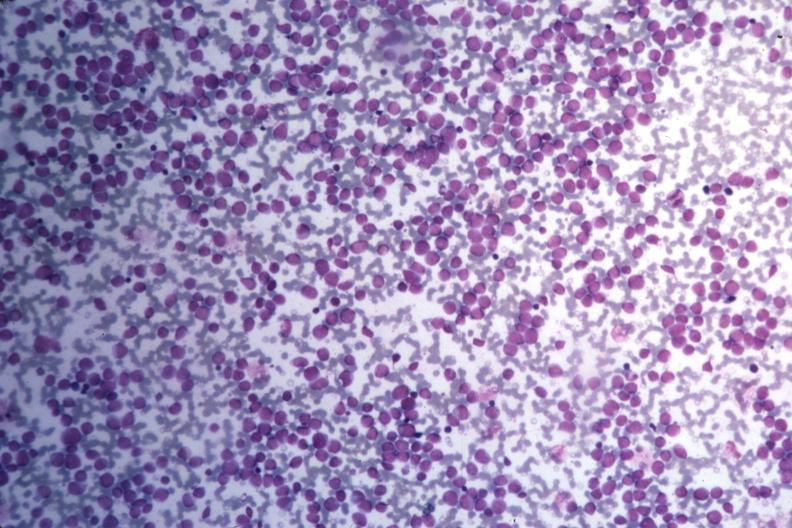s acute myelogenous leukemia present?
Answer the question using a single word or phrase. Yes 